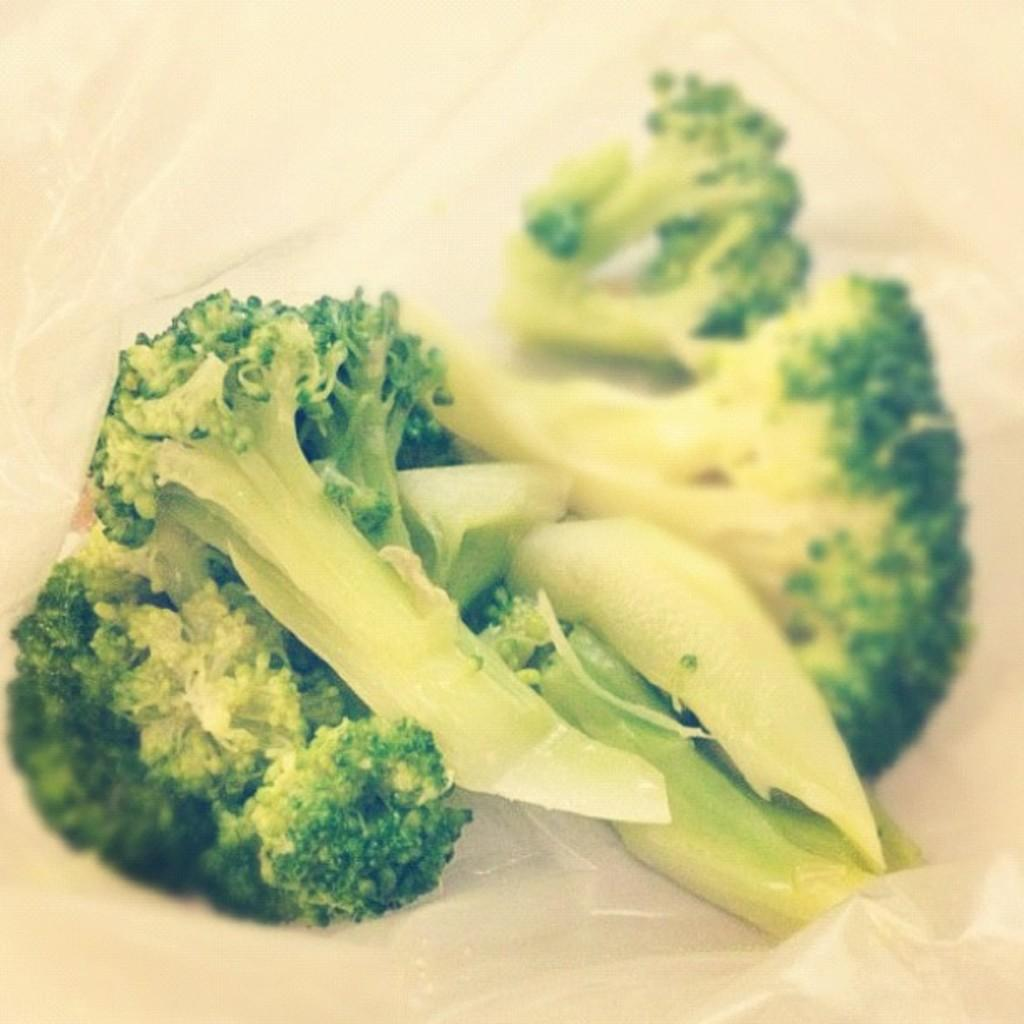What type of vegetable is visible in the image? There are broccoli pieces in the image. How are the broccoli pieces contained or protected in the image? The broccoli pieces are in a cover. What is the income of the person who prepared the broccoli in the image? There is no information about the person who prepared the broccoli or their income in the image. 